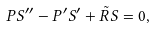Convert formula to latex. <formula><loc_0><loc_0><loc_500><loc_500>P S ^ { \prime \prime } - P ^ { \prime } S ^ { \prime } + \tilde { R } S = 0 ,</formula> 